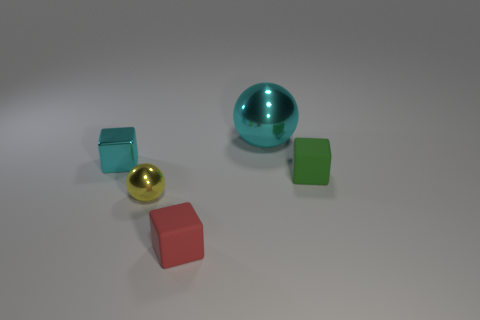Add 3 small red rubber things. How many objects exist? 8 Subtract all balls. How many objects are left? 3 Subtract 0 purple cubes. How many objects are left? 5 Subtract all tiny yellow spheres. Subtract all green objects. How many objects are left? 3 Add 1 small cyan things. How many small cyan things are left? 2 Add 1 large metallic things. How many large metallic things exist? 2 